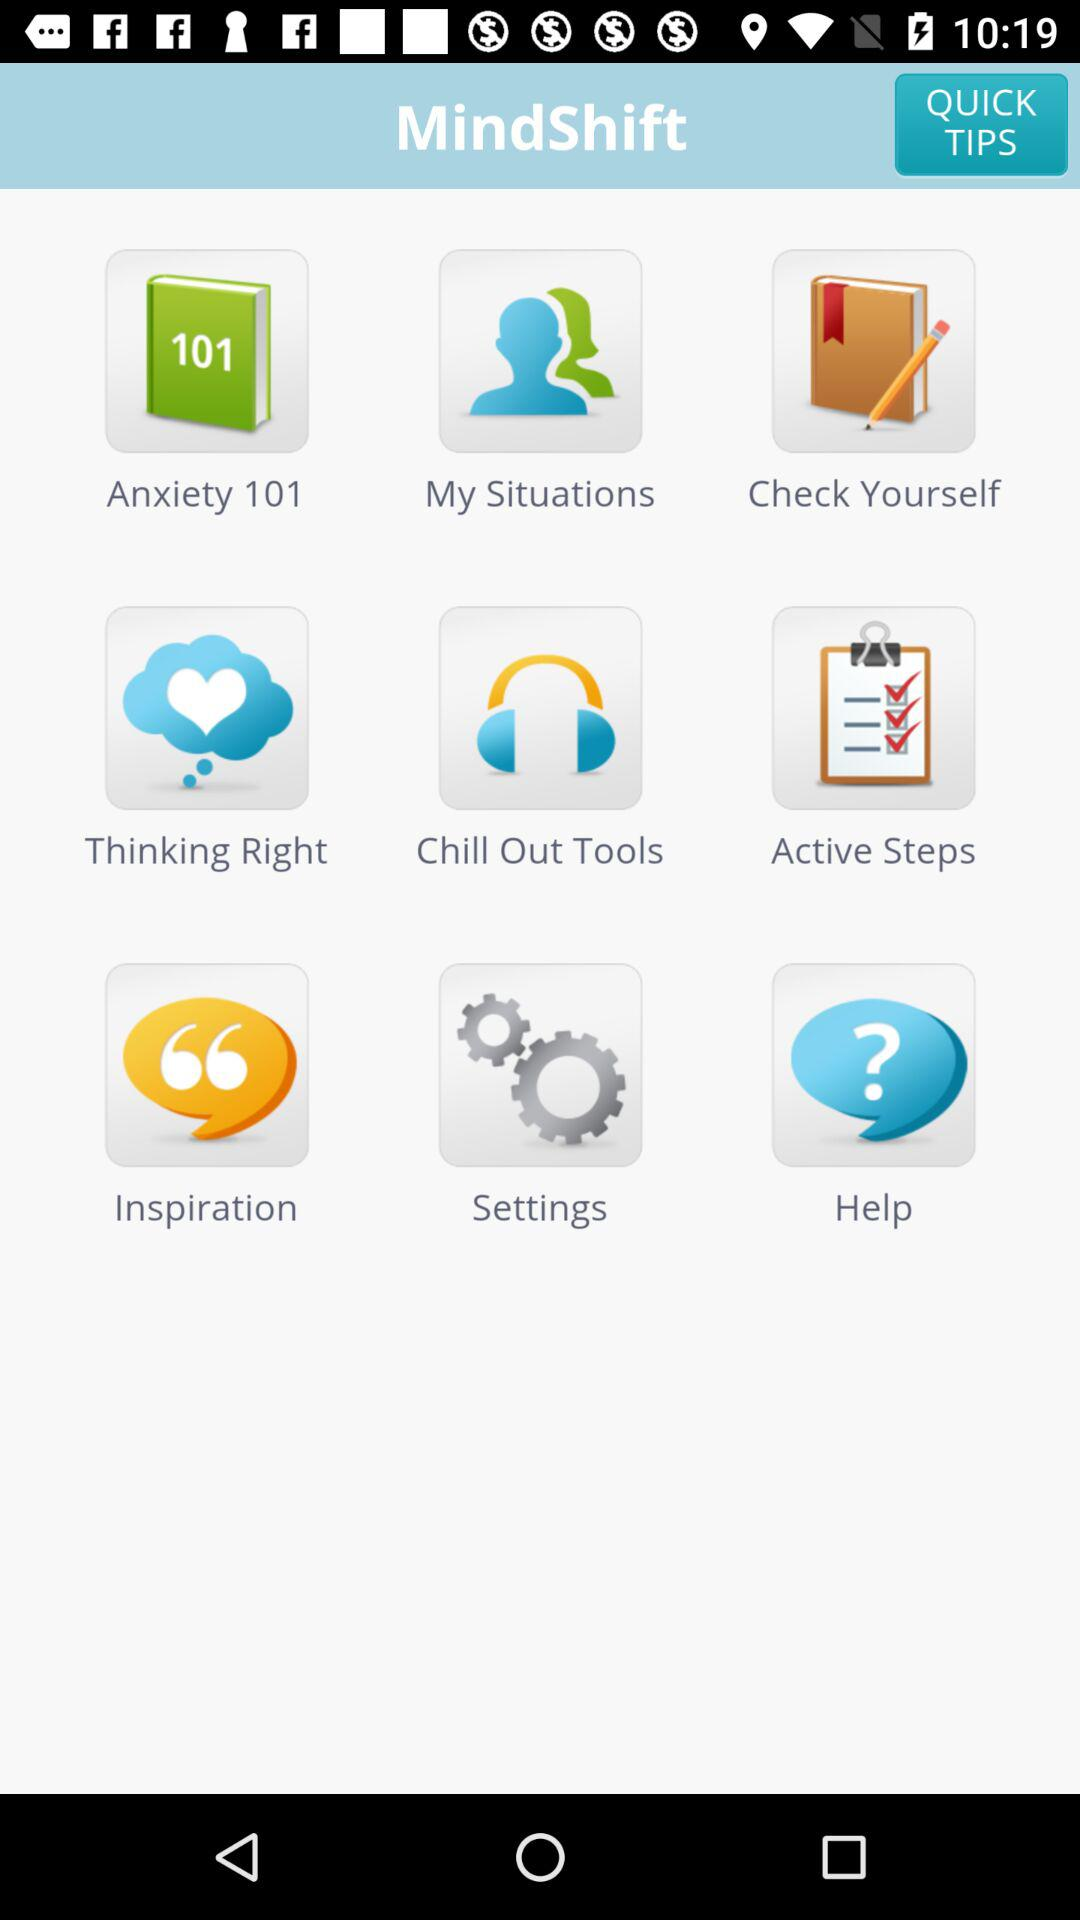What are the available options? The available options are "Anxiety 101", "My Situations", "Check Yourself", "Thinking Right", "Chill Out Tools", "Active Steps", "Inspiration", "Settings" and "Help". 